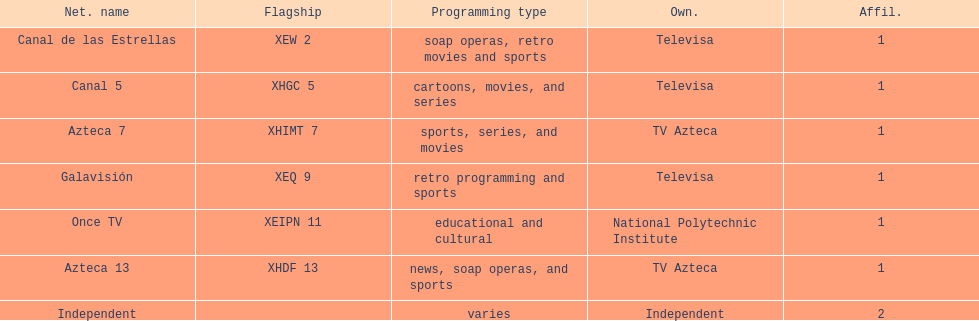How many networks does tv azteca own? 2. I'm looking to parse the entire table for insights. Could you assist me with that? {'header': ['Net. name', 'Flagship', 'Programming type', 'Own.', 'Affil.'], 'rows': [['Canal de las Estrellas', 'XEW 2', 'soap operas, retro movies and sports', 'Televisa', '1'], ['Canal 5', 'XHGC 5', 'cartoons, movies, and series', 'Televisa', '1'], ['Azteca 7', 'XHIMT 7', 'sports, series, and movies', 'TV Azteca', '1'], ['Galavisión', 'XEQ 9', 'retro programming and sports', 'Televisa', '1'], ['Once TV', 'XEIPN 11', 'educational and cultural', 'National Polytechnic Institute', '1'], ['Azteca 13', 'XHDF 13', 'news, soap operas, and sports', 'TV Azteca', '1'], ['Independent', '', 'varies', 'Independent', '2']]} 